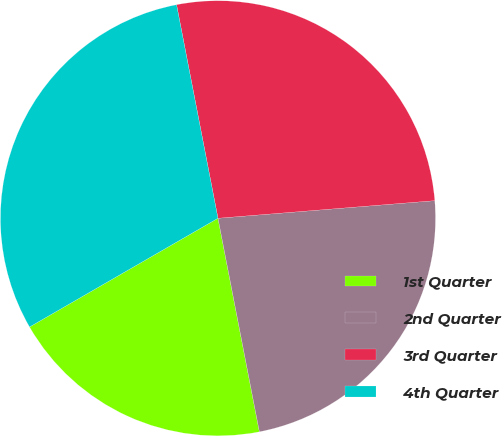Convert chart to OTSL. <chart><loc_0><loc_0><loc_500><loc_500><pie_chart><fcel>1st Quarter<fcel>2nd Quarter<fcel>3rd Quarter<fcel>4th Quarter<nl><fcel>19.72%<fcel>23.24%<fcel>26.76%<fcel>30.28%<nl></chart> 